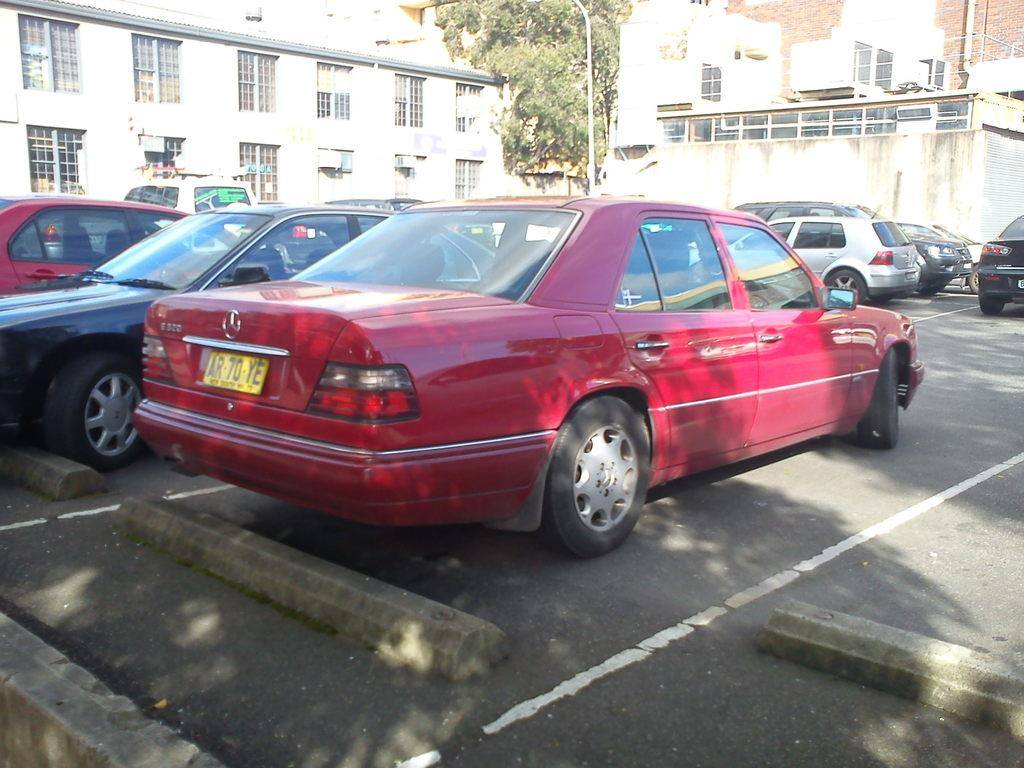What can be seen on the road in the image? There are cars on the road in the image. What is visible in the background of the image? There is a tree, a pole, and buildings in the background of the image. What type of needle is being used to sew the tree in the image? There is no needle present in the image, as the tree is a natural object and not being sewn. 